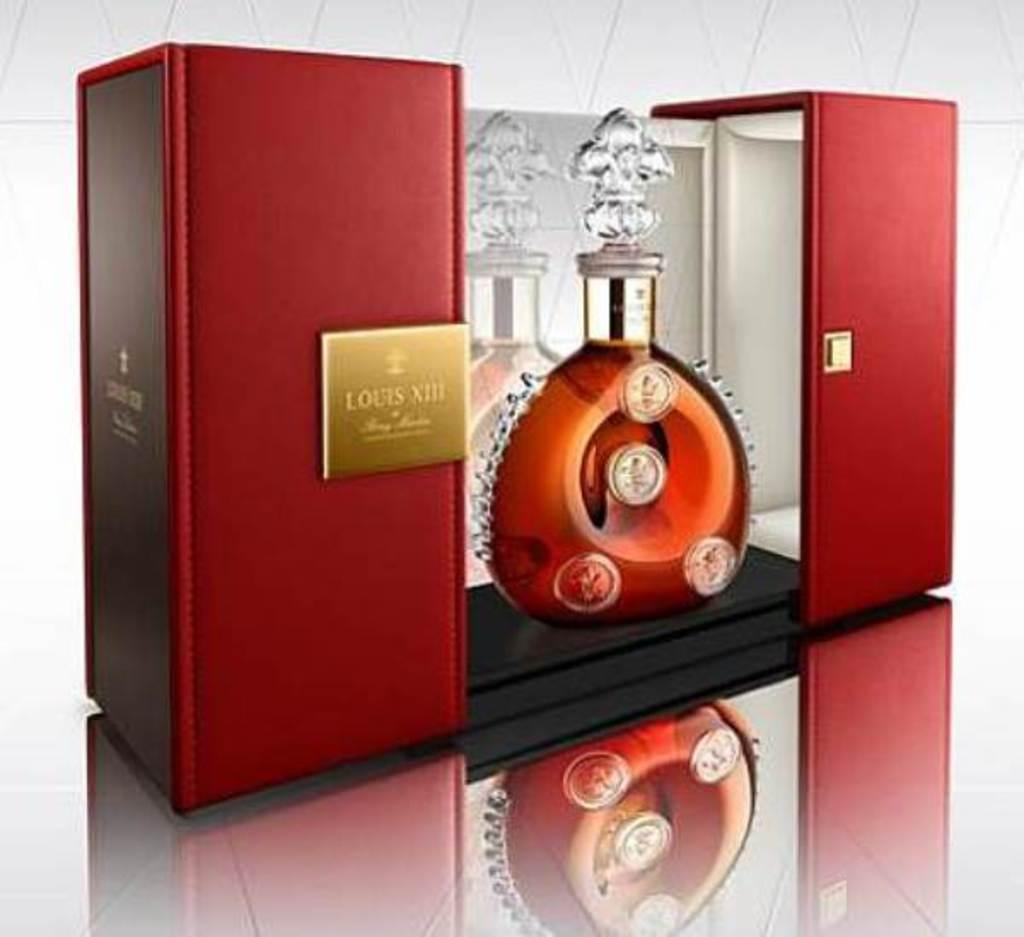<image>
Write a terse but informative summary of the picture. A glass of orange liquid in a box with the label Louis XIII. 